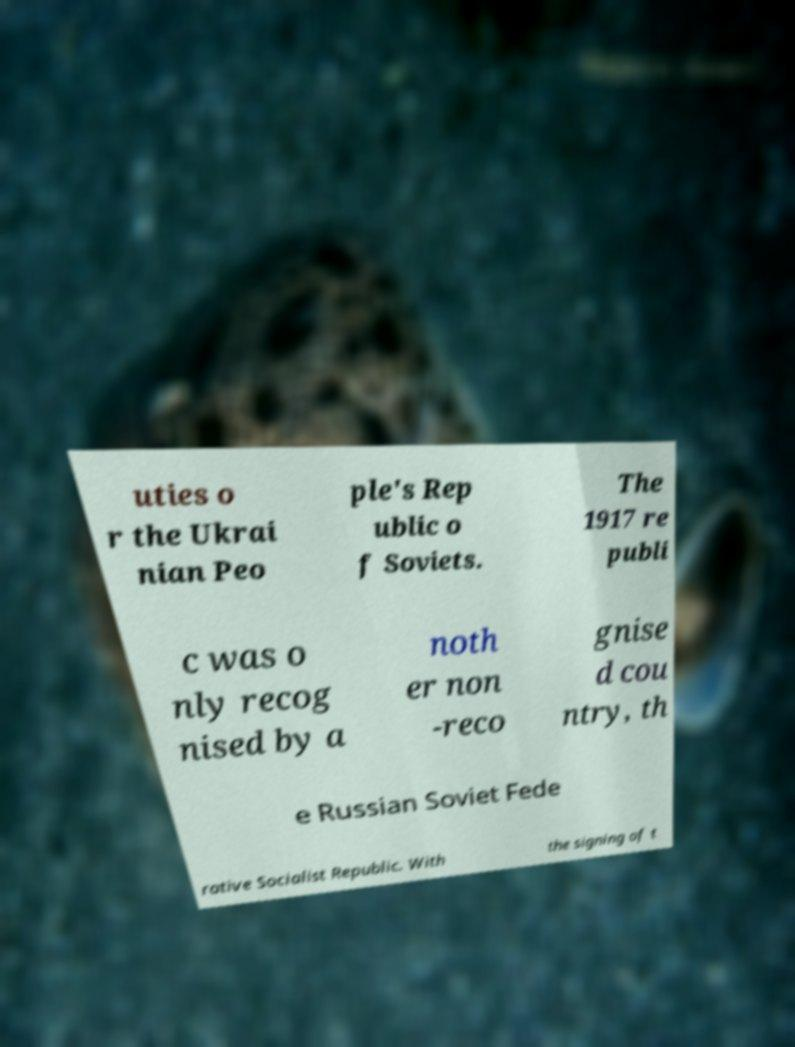Can you accurately transcribe the text from the provided image for me? uties o r the Ukrai nian Peo ple's Rep ublic o f Soviets. The 1917 re publi c was o nly recog nised by a noth er non -reco gnise d cou ntry, th e Russian Soviet Fede rative Socialist Republic. With the signing of t 